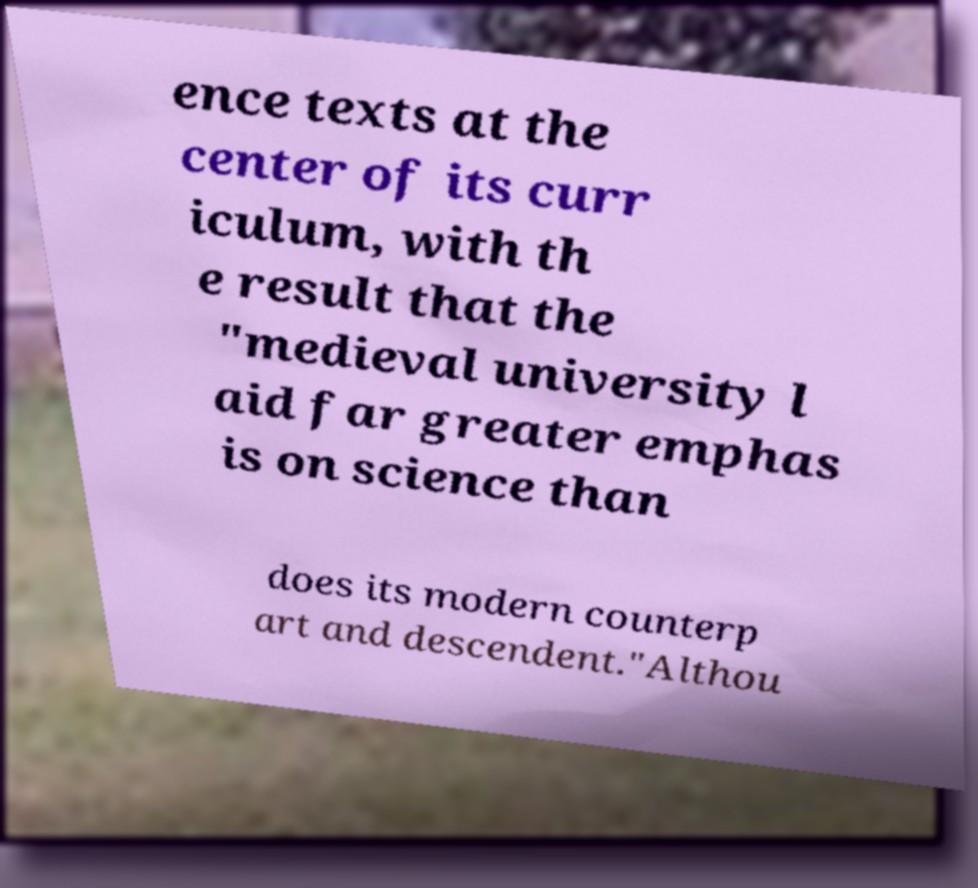What messages or text are displayed in this image? I need them in a readable, typed format. ence texts at the center of its curr iculum, with th e result that the "medieval university l aid far greater emphas is on science than does its modern counterp art and descendent."Althou 